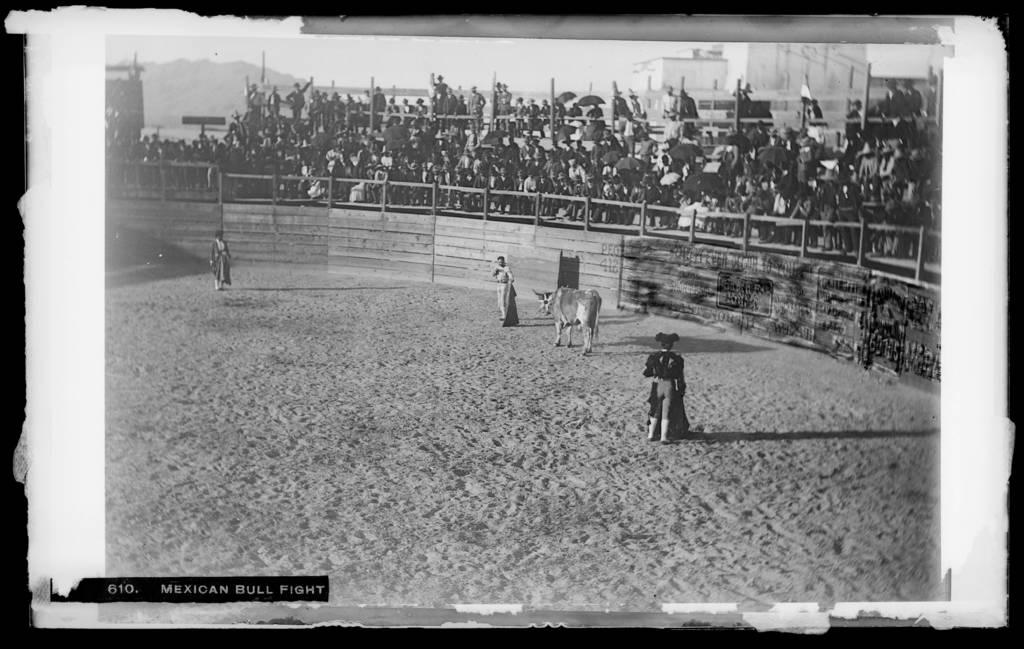What is the color scheme of the image? The image is black and white. How many people are standing on the sandy land? There are three persons standing on sandy land. What is in the middle of the three persons? There is a bull in the middle of the three persons. Can you describe the people behind a fence? There are many people standing behind a fence. What type of oil can be seen being extracted from the harbor in the image? There is no harbor or oil extraction present in the image. What activity are the people behind the fence participating in? The image does not provide enough information to determine the specific activity the people behind the fence are participating in. 